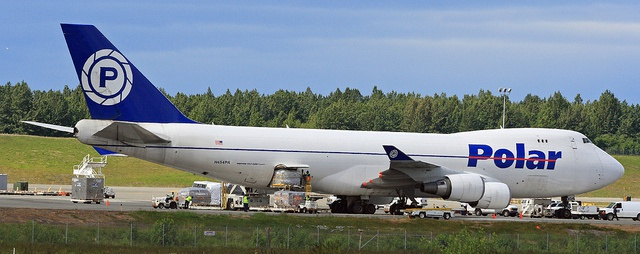Describe the objects in this image and their specific colors. I can see airplane in darkgray, lightgray, navy, and gray tones, truck in darkgray, lightgray, black, and gray tones, car in darkgray, lightgray, black, and gray tones, car in darkgray, black, gray, and olive tones, and car in darkgray, black, white, and gray tones in this image. 